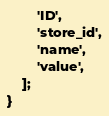Convert code to text. <code><loc_0><loc_0><loc_500><loc_500><_PHP_>        'ID',
        'store_id',
        'name',
        'value',
    ];
}
</code> 